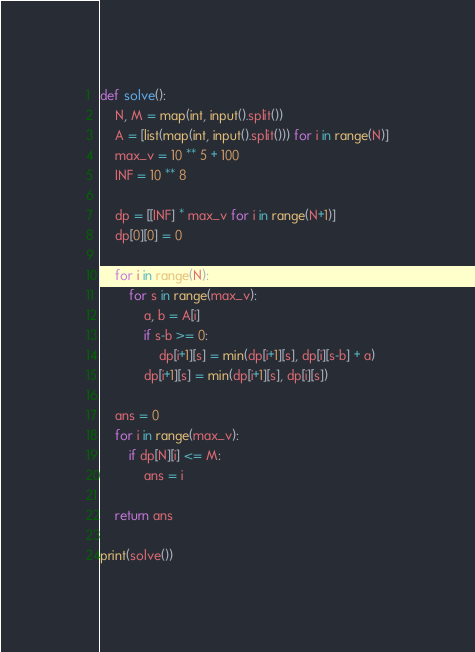Convert code to text. <code><loc_0><loc_0><loc_500><loc_500><_Python_>def solve():
    N, M = map(int, input().split())
    A = [list(map(int, input().split())) for i in range(N)]
    max_v = 10 ** 5 + 100
    INF = 10 ** 8
    
    dp = [[INF] * max_v for i in range(N+1)]
    dp[0][0] = 0

    for i in range(N):
        for s in range(max_v):
            a, b = A[i]
            if s-b >= 0:
                dp[i+1][s] = min(dp[i+1][s], dp[i][s-b] + a)
            dp[i+1][s] = min(dp[i+1][s], dp[i][s])
    
    ans = 0
    for i in range(max_v):
        if dp[N][i] <= M:
            ans = i
    
    return ans

print(solve())</code> 